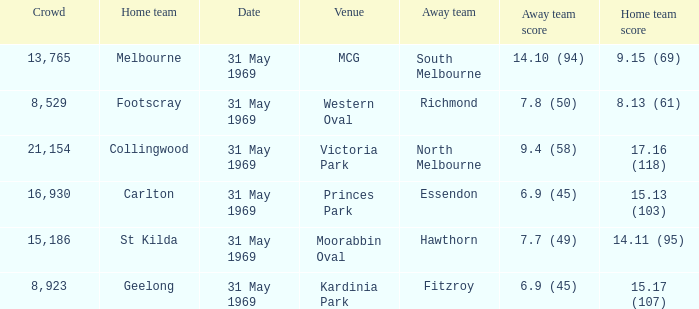Which home side scored 1 St Kilda. 